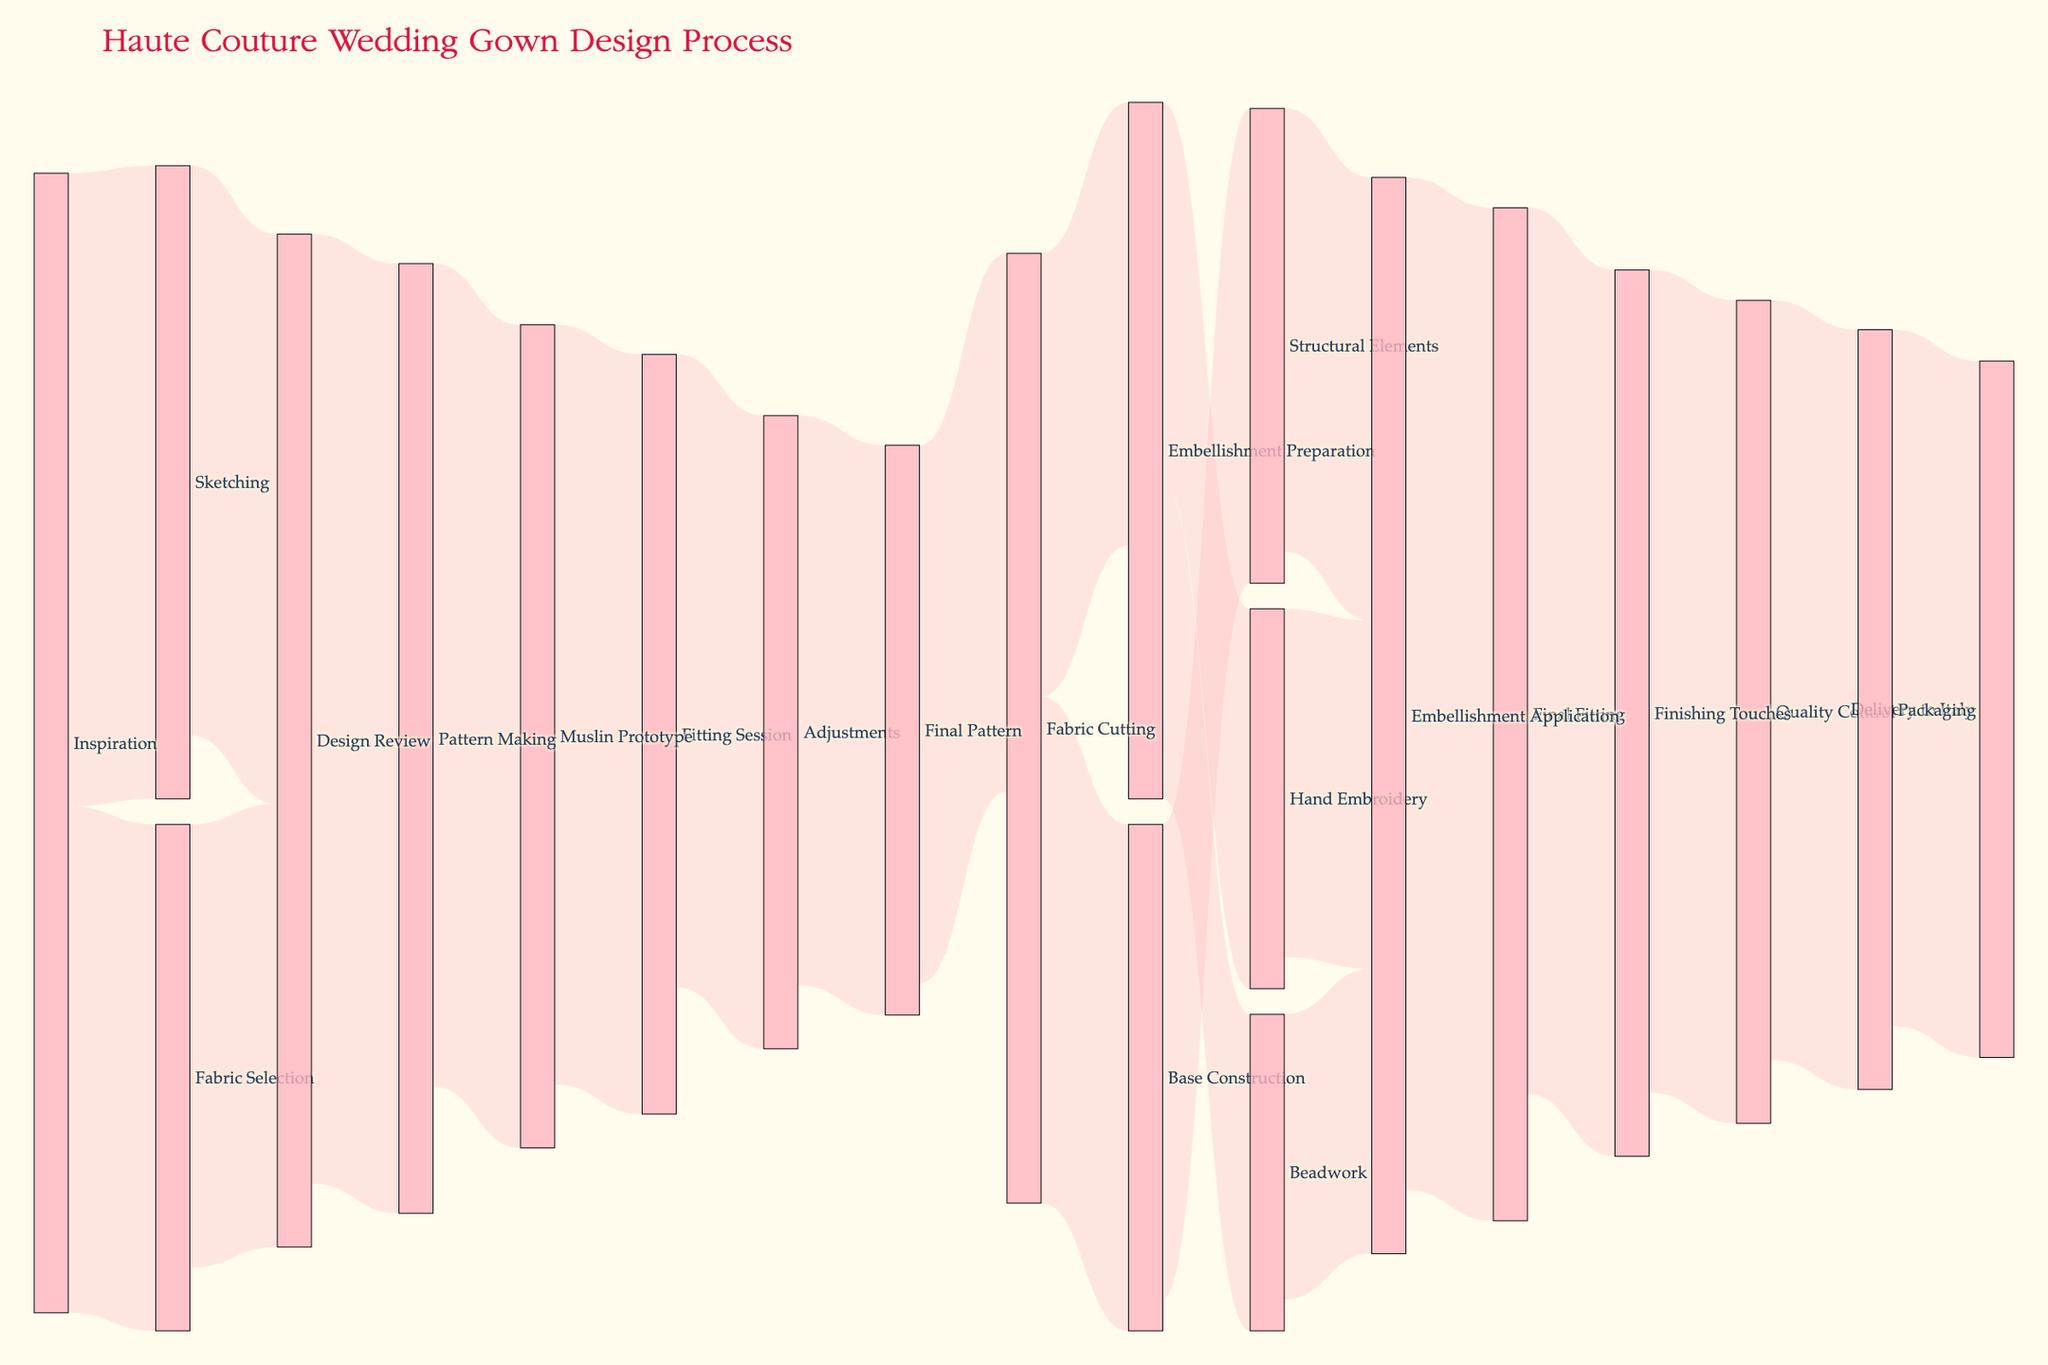What is the title of the figure? The title is usually placed at the top of the figure. It provides a summary of the entire visual representation.
Answer: Haute Couture Wedding Gown Design Process How many phases are involved in the design process? Count the unique labels in the nodes of the Sankey diagram. The phases are different stages such as Inspiration, Sketching, etc. There are 21 unique phases.
Answer: 21 What phase comes after 'Final Pattern'? Follow the flow of the process from 'Final Pattern' to its subsequent node. 'Final Pattern' links to 'Fabric Cutting'.
Answer: Fabric Cutting What is the total value flowing into 'Embellishment Application'? Sum the values of all links leading into 'Embellishment Application'. These are from 'Hand Embroidery' (55), 'Beadwork' (45), and 'Structural Elements' (70). Calculate 55 + 45 + 70.
Answer: 170 Which phase has the highest outgoing value? Compare all outgoing values of each phase and identify the one with the maximum. 'Final Fitting' has the highest outgoing value of 140.
Answer: Final Fitting Is the value of 'Beadwork' to 'Embellishment Application' less than 'Hand Embroidery' to 'Embellishment Application'? Compare the values of these specific links. 'Beadwork' to 'Embellishment Application' is 45 and 'Hand Embroidery' to 'Embellishment Application' is 55. 45 < 55.
Answer: Yes What is the total value involved in the 'Embellishment Preparation' phase? Sum the values of links coming into and going out of 'Embellishment Preparation'. It receives 70 from 'Fabric Cutting', and sends 60 to 'Hand Embroidery' and 50 to 'Beadwork'. Calculate 70 + 60 + 50.
Answer: 180 How do the values compare between 'Sketching' to 'Design Review' and 'Fabric Selection' to 'Design Review'? Compare the values of these specific links. 'Sketching' to 'Design Review' is 90, 'Fabric Selection' to 'Design Review' is 70. 90 > 70.
Answer: 'Sketching' to 'Design Review' is greater What is the final destination of the gown design process? Follow the final link in the diagram. The flow ends at 'Delivery to Italy'.
Answer: Delivery to Italy 